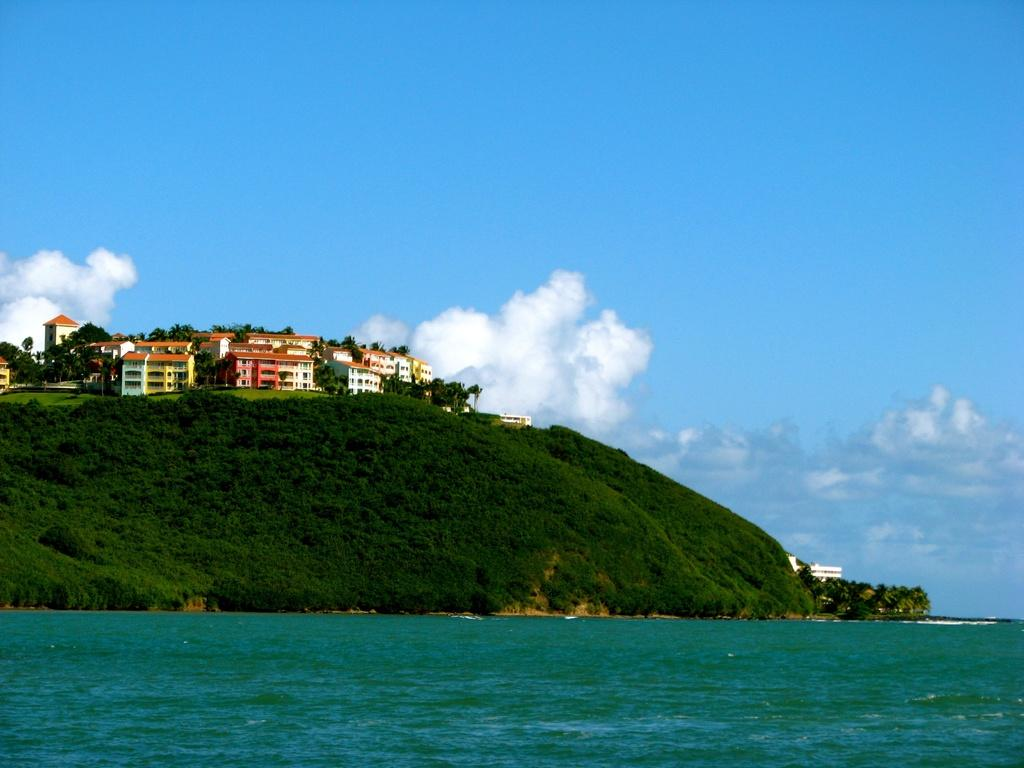What type of structures can be seen in the image? There are buildings in the image. What other natural elements are present in the image? There are trees and water visible in the image. What is the color of the sky in the image? The sky is blue and white in color. What type of border is depicted in the image? There is no border depicted in the image; it features buildings, trees, water, and a blue and white sky. Does the image convey a sense of respect for the environment? The image itself does not convey a sense of respect for the environment, as it is a static representation of buildings, trees, water, and a blue and white sky. 